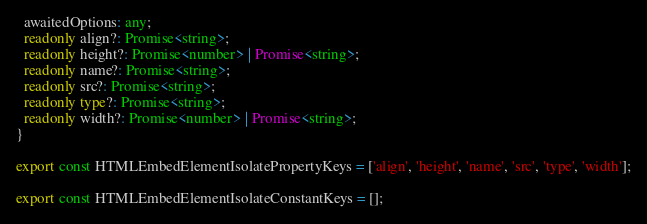Convert code to text. <code><loc_0><loc_0><loc_500><loc_500><_TypeScript_>  awaitedOptions: any;
  readonly align?: Promise<string>;
  readonly height?: Promise<number> | Promise<string>;
  readonly name?: Promise<string>;
  readonly src?: Promise<string>;
  readonly type?: Promise<string>;
  readonly width?: Promise<number> | Promise<string>;
}

export const HTMLEmbedElementIsolatePropertyKeys = ['align', 'height', 'name', 'src', 'type', 'width'];

export const HTMLEmbedElementIsolateConstantKeys = [];
</code> 